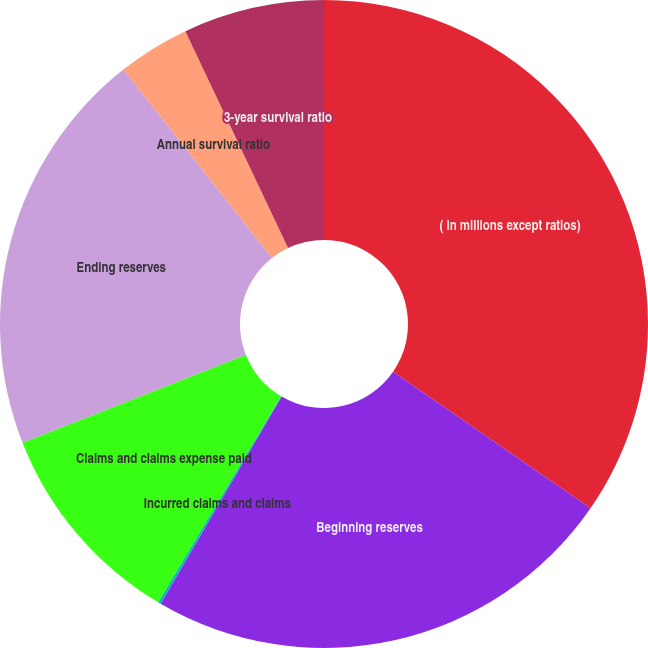<chart> <loc_0><loc_0><loc_500><loc_500><pie_chart><fcel>( in millions except ratios)<fcel>Beginning reserves<fcel>Incurred claims and claims<fcel>Claims and claims expense paid<fcel>Ending reserves<fcel>Annual survival ratio<fcel>3-year survival ratio<nl><fcel>34.63%<fcel>23.79%<fcel>0.14%<fcel>10.48%<fcel>20.34%<fcel>3.59%<fcel>7.04%<nl></chart> 